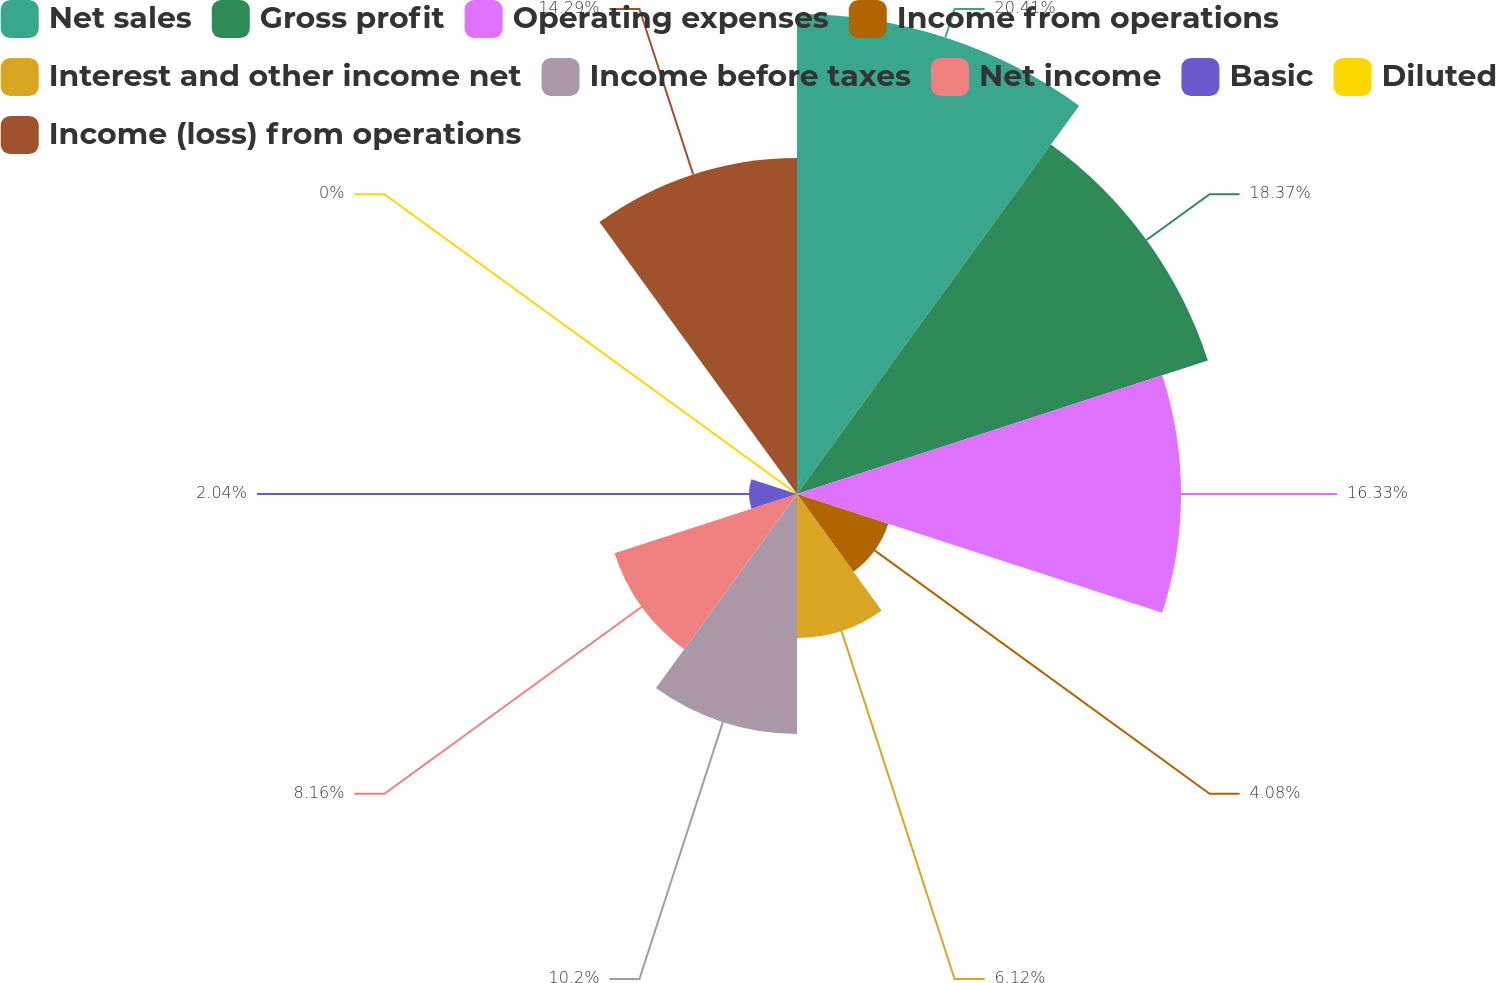<chart> <loc_0><loc_0><loc_500><loc_500><pie_chart><fcel>Net sales<fcel>Gross profit<fcel>Operating expenses<fcel>Income from operations<fcel>Interest and other income net<fcel>Income before taxes<fcel>Net income<fcel>Basic<fcel>Diluted<fcel>Income (loss) from operations<nl><fcel>20.41%<fcel>18.37%<fcel>16.33%<fcel>4.08%<fcel>6.12%<fcel>10.2%<fcel>8.16%<fcel>2.04%<fcel>0.0%<fcel>14.29%<nl></chart> 